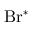Convert formula to latex. <formula><loc_0><loc_0><loc_500><loc_500>B r ^ { * }</formula> 